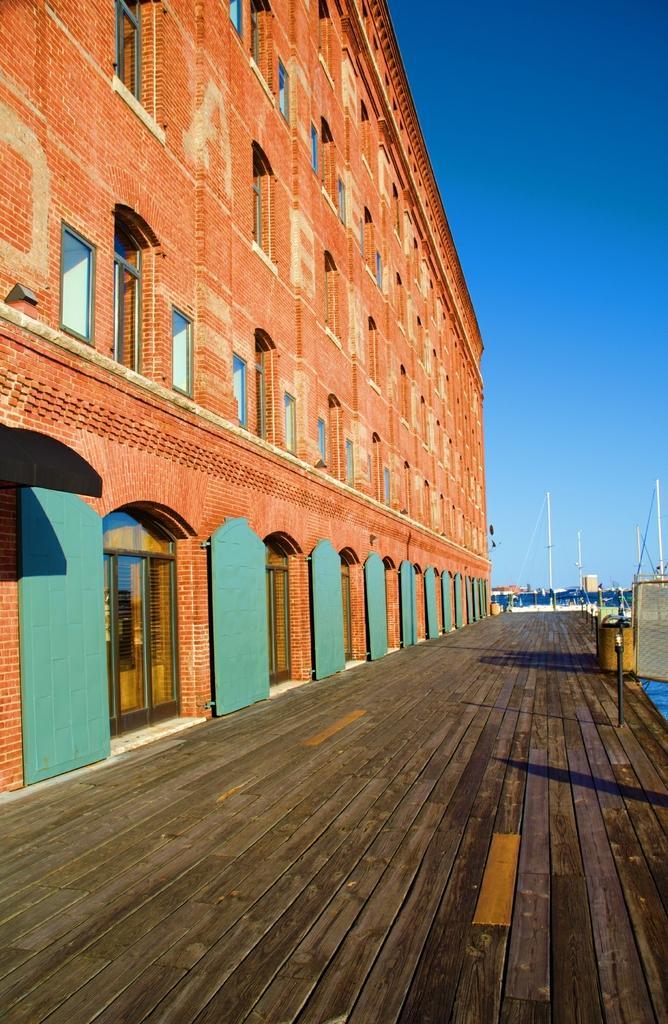Describe this image in one or two sentences. In this image on the left side there is a building at the bottom there is walkway, and in the background there are some poles. At the top of the image there is sky. 